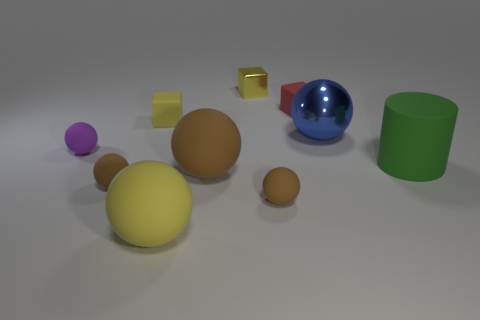Is there a big sphere of the same color as the shiny cube?
Keep it short and to the point. Yes. What shape is the green rubber object?
Your answer should be compact. Cylinder. There is a metal object that is in front of the metallic object behind the big metal sphere; what is its color?
Provide a short and direct response. Blue. What is the size of the metal thing that is right of the small yellow metallic thing?
Keep it short and to the point. Large. Is there a yellow sphere made of the same material as the green cylinder?
Make the answer very short. Yes. How many purple rubber objects are the same shape as the big brown thing?
Offer a very short reply. 1. What shape is the small brown object that is right of the small yellow thing that is on the right side of the yellow matte thing in front of the metal sphere?
Make the answer very short. Sphere. What material is the small thing that is left of the yellow sphere and behind the purple rubber object?
Provide a short and direct response. Rubber. There is a block that is in front of the red rubber thing; does it have the same size as the large blue sphere?
Make the answer very short. No. Are there more big things left of the blue shiny ball than blue objects that are behind the small yellow metallic block?
Keep it short and to the point. Yes. 